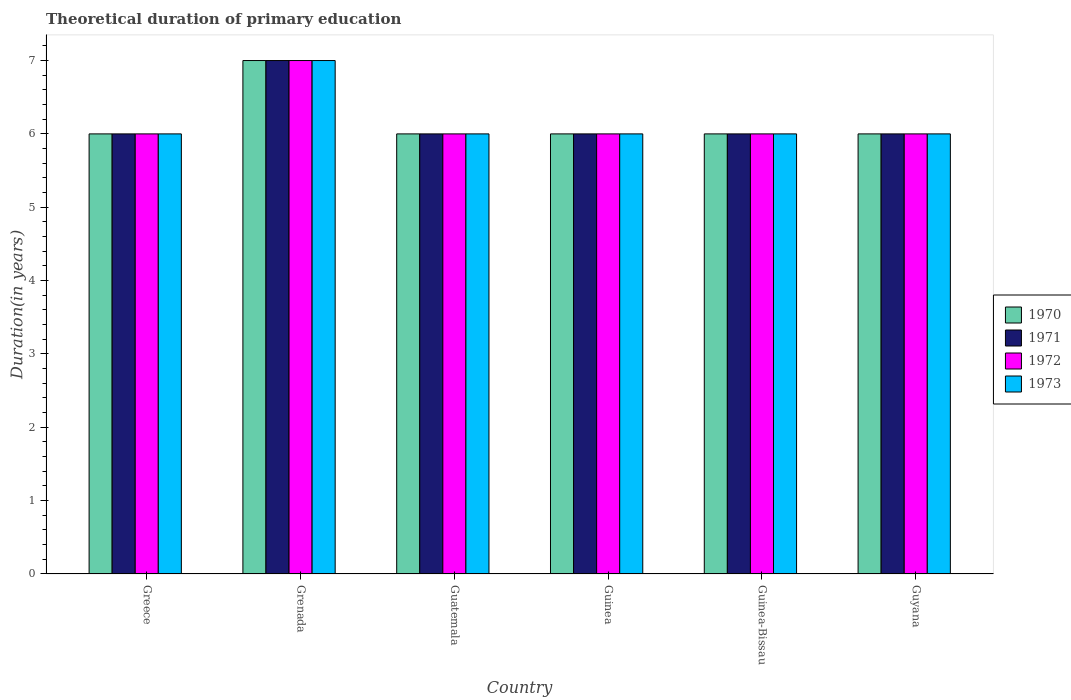How many groups of bars are there?
Your answer should be compact. 6. Are the number of bars on each tick of the X-axis equal?
Keep it short and to the point. Yes. How many bars are there on the 5th tick from the left?
Offer a very short reply. 4. How many bars are there on the 4th tick from the right?
Make the answer very short. 4. What is the label of the 1st group of bars from the left?
Provide a short and direct response. Greece. In how many cases, is the number of bars for a given country not equal to the number of legend labels?
Your response must be concise. 0. Across all countries, what is the maximum total theoretical duration of primary education in 1971?
Your answer should be very brief. 7. In which country was the total theoretical duration of primary education in 1973 maximum?
Make the answer very short. Grenada. In which country was the total theoretical duration of primary education in 1971 minimum?
Ensure brevity in your answer.  Greece. What is the difference between the total theoretical duration of primary education in 1971 in Guatemala and the total theoretical duration of primary education in 1972 in Guinea?
Offer a very short reply. 0. What is the average total theoretical duration of primary education in 1972 per country?
Your answer should be compact. 6.17. What is the difference between the total theoretical duration of primary education of/in 1971 and total theoretical duration of primary education of/in 1970 in Guinea?
Offer a terse response. 0. In how many countries, is the total theoretical duration of primary education in 1970 greater than 1.6 years?
Ensure brevity in your answer.  6. What is the ratio of the total theoretical duration of primary education in 1972 in Grenada to that in Guyana?
Ensure brevity in your answer.  1.17. Is the difference between the total theoretical duration of primary education in 1971 in Guinea-Bissau and Guyana greater than the difference between the total theoretical duration of primary education in 1970 in Guinea-Bissau and Guyana?
Provide a succinct answer. No. What is the difference between the highest and the lowest total theoretical duration of primary education in 1972?
Keep it short and to the point. 1. In how many countries, is the total theoretical duration of primary education in 1971 greater than the average total theoretical duration of primary education in 1971 taken over all countries?
Provide a short and direct response. 1. What does the 4th bar from the left in Greece represents?
Offer a terse response. 1973. What does the 4th bar from the right in Guinea-Bissau represents?
Give a very brief answer. 1970. Are all the bars in the graph horizontal?
Give a very brief answer. No. How many countries are there in the graph?
Your answer should be very brief. 6. Are the values on the major ticks of Y-axis written in scientific E-notation?
Offer a very short reply. No. Does the graph contain any zero values?
Your answer should be very brief. No. Does the graph contain grids?
Provide a short and direct response. No. How many legend labels are there?
Ensure brevity in your answer.  4. What is the title of the graph?
Provide a short and direct response. Theoretical duration of primary education. What is the label or title of the Y-axis?
Ensure brevity in your answer.  Duration(in years). What is the Duration(in years) in 1970 in Greece?
Give a very brief answer. 6. What is the Duration(in years) in 1972 in Greece?
Offer a very short reply. 6. What is the Duration(in years) of 1970 in Grenada?
Provide a succinct answer. 7. What is the Duration(in years) in 1972 in Grenada?
Ensure brevity in your answer.  7. What is the Duration(in years) in 1973 in Grenada?
Offer a very short reply. 7. What is the Duration(in years) of 1972 in Guatemala?
Give a very brief answer. 6. What is the Duration(in years) in 1973 in Guatemala?
Your answer should be very brief. 6. What is the Duration(in years) of 1970 in Guinea?
Offer a very short reply. 6. What is the Duration(in years) in 1971 in Guinea?
Keep it short and to the point. 6. What is the Duration(in years) in 1973 in Guinea?
Offer a very short reply. 6. What is the Duration(in years) in 1971 in Guinea-Bissau?
Offer a very short reply. 6. What is the Duration(in years) of 1970 in Guyana?
Keep it short and to the point. 6. What is the Duration(in years) of 1971 in Guyana?
Your answer should be very brief. 6. Across all countries, what is the maximum Duration(in years) in 1973?
Your answer should be compact. 7. What is the total Duration(in years) of 1971 in the graph?
Provide a short and direct response. 37. What is the total Duration(in years) of 1972 in the graph?
Offer a very short reply. 37. What is the difference between the Duration(in years) of 1972 in Greece and that in Grenada?
Your answer should be very brief. -1. What is the difference between the Duration(in years) of 1973 in Greece and that in Grenada?
Keep it short and to the point. -1. What is the difference between the Duration(in years) of 1971 in Greece and that in Guatemala?
Your answer should be very brief. 0. What is the difference between the Duration(in years) of 1972 in Greece and that in Guatemala?
Ensure brevity in your answer.  0. What is the difference between the Duration(in years) of 1972 in Greece and that in Guinea?
Keep it short and to the point. 0. What is the difference between the Duration(in years) in 1973 in Greece and that in Guinea?
Give a very brief answer. 0. What is the difference between the Duration(in years) of 1971 in Greece and that in Guinea-Bissau?
Your answer should be very brief. 0. What is the difference between the Duration(in years) of 1972 in Greece and that in Guinea-Bissau?
Provide a succinct answer. 0. What is the difference between the Duration(in years) of 1971 in Greece and that in Guyana?
Give a very brief answer. 0. What is the difference between the Duration(in years) in 1972 in Greece and that in Guyana?
Keep it short and to the point. 0. What is the difference between the Duration(in years) of 1973 in Greece and that in Guyana?
Your response must be concise. 0. What is the difference between the Duration(in years) in 1970 in Grenada and that in Guatemala?
Your response must be concise. 1. What is the difference between the Duration(in years) of 1971 in Grenada and that in Guatemala?
Offer a terse response. 1. What is the difference between the Duration(in years) of 1972 in Grenada and that in Guatemala?
Your response must be concise. 1. What is the difference between the Duration(in years) in 1972 in Grenada and that in Guinea?
Provide a succinct answer. 1. What is the difference between the Duration(in years) in 1973 in Grenada and that in Guinea?
Give a very brief answer. 1. What is the difference between the Duration(in years) in 1970 in Grenada and that in Guinea-Bissau?
Offer a very short reply. 1. What is the difference between the Duration(in years) of 1973 in Grenada and that in Guinea-Bissau?
Keep it short and to the point. 1. What is the difference between the Duration(in years) in 1970 in Guatemala and that in Guinea?
Provide a succinct answer. 0. What is the difference between the Duration(in years) of 1971 in Guatemala and that in Guinea?
Provide a succinct answer. 0. What is the difference between the Duration(in years) in 1972 in Guatemala and that in Guinea?
Your answer should be very brief. 0. What is the difference between the Duration(in years) of 1971 in Guatemala and that in Guinea-Bissau?
Your response must be concise. 0. What is the difference between the Duration(in years) in 1973 in Guatemala and that in Guinea-Bissau?
Offer a very short reply. 0. What is the difference between the Duration(in years) in 1970 in Guatemala and that in Guyana?
Ensure brevity in your answer.  0. What is the difference between the Duration(in years) in 1972 in Guatemala and that in Guyana?
Offer a very short reply. 0. What is the difference between the Duration(in years) of 1971 in Guinea and that in Guyana?
Your answer should be very brief. 0. What is the difference between the Duration(in years) of 1970 in Guinea-Bissau and that in Guyana?
Your answer should be very brief. 0. What is the difference between the Duration(in years) in 1972 in Guinea-Bissau and that in Guyana?
Your answer should be compact. 0. What is the difference between the Duration(in years) of 1970 in Greece and the Duration(in years) of 1971 in Grenada?
Make the answer very short. -1. What is the difference between the Duration(in years) of 1970 in Greece and the Duration(in years) of 1972 in Grenada?
Your response must be concise. -1. What is the difference between the Duration(in years) of 1970 in Greece and the Duration(in years) of 1973 in Grenada?
Offer a very short reply. -1. What is the difference between the Duration(in years) in 1971 in Greece and the Duration(in years) in 1972 in Guatemala?
Give a very brief answer. 0. What is the difference between the Duration(in years) in 1971 in Greece and the Duration(in years) in 1973 in Guatemala?
Your response must be concise. 0. What is the difference between the Duration(in years) in 1971 in Greece and the Duration(in years) in 1973 in Guinea?
Your answer should be compact. 0. What is the difference between the Duration(in years) of 1970 in Greece and the Duration(in years) of 1973 in Guinea-Bissau?
Keep it short and to the point. 0. What is the difference between the Duration(in years) in 1971 in Greece and the Duration(in years) in 1972 in Guinea-Bissau?
Keep it short and to the point. 0. What is the difference between the Duration(in years) in 1971 in Greece and the Duration(in years) in 1973 in Guinea-Bissau?
Offer a very short reply. 0. What is the difference between the Duration(in years) in 1972 in Greece and the Duration(in years) in 1973 in Guinea-Bissau?
Give a very brief answer. 0. What is the difference between the Duration(in years) in 1970 in Greece and the Duration(in years) in 1971 in Guyana?
Offer a very short reply. 0. What is the difference between the Duration(in years) of 1972 in Greece and the Duration(in years) of 1973 in Guyana?
Keep it short and to the point. 0. What is the difference between the Duration(in years) of 1970 in Grenada and the Duration(in years) of 1973 in Guatemala?
Ensure brevity in your answer.  1. What is the difference between the Duration(in years) in 1971 in Grenada and the Duration(in years) in 1973 in Guatemala?
Your response must be concise. 1. What is the difference between the Duration(in years) in 1972 in Grenada and the Duration(in years) in 1973 in Guatemala?
Your answer should be compact. 1. What is the difference between the Duration(in years) in 1970 in Grenada and the Duration(in years) in 1972 in Guinea?
Ensure brevity in your answer.  1. What is the difference between the Duration(in years) of 1972 in Grenada and the Duration(in years) of 1973 in Guinea?
Make the answer very short. 1. What is the difference between the Duration(in years) of 1971 in Grenada and the Duration(in years) of 1972 in Guinea-Bissau?
Your response must be concise. 1. What is the difference between the Duration(in years) of 1972 in Grenada and the Duration(in years) of 1973 in Guinea-Bissau?
Offer a very short reply. 1. What is the difference between the Duration(in years) of 1970 in Grenada and the Duration(in years) of 1973 in Guyana?
Ensure brevity in your answer.  1. What is the difference between the Duration(in years) in 1971 in Grenada and the Duration(in years) in 1972 in Guyana?
Offer a very short reply. 1. What is the difference between the Duration(in years) of 1971 in Grenada and the Duration(in years) of 1973 in Guyana?
Keep it short and to the point. 1. What is the difference between the Duration(in years) in 1970 in Guatemala and the Duration(in years) in 1972 in Guinea?
Your answer should be very brief. 0. What is the difference between the Duration(in years) in 1970 in Guatemala and the Duration(in years) in 1973 in Guinea?
Ensure brevity in your answer.  0. What is the difference between the Duration(in years) of 1972 in Guatemala and the Duration(in years) of 1973 in Guinea?
Provide a succinct answer. 0. What is the difference between the Duration(in years) of 1970 in Guatemala and the Duration(in years) of 1971 in Guinea-Bissau?
Provide a succinct answer. 0. What is the difference between the Duration(in years) in 1970 in Guatemala and the Duration(in years) in 1972 in Guinea-Bissau?
Your response must be concise. 0. What is the difference between the Duration(in years) of 1970 in Guatemala and the Duration(in years) of 1973 in Guinea-Bissau?
Ensure brevity in your answer.  0. What is the difference between the Duration(in years) in 1971 in Guatemala and the Duration(in years) in 1972 in Guinea-Bissau?
Your answer should be compact. 0. What is the difference between the Duration(in years) in 1970 in Guatemala and the Duration(in years) in 1971 in Guyana?
Your response must be concise. 0. What is the difference between the Duration(in years) of 1970 in Guatemala and the Duration(in years) of 1973 in Guyana?
Offer a terse response. 0. What is the difference between the Duration(in years) in 1971 in Guatemala and the Duration(in years) in 1973 in Guyana?
Your answer should be compact. 0. What is the difference between the Duration(in years) in 1972 in Guatemala and the Duration(in years) in 1973 in Guyana?
Offer a very short reply. 0. What is the difference between the Duration(in years) in 1970 in Guinea and the Duration(in years) in 1971 in Guinea-Bissau?
Give a very brief answer. 0. What is the difference between the Duration(in years) of 1970 in Guinea and the Duration(in years) of 1971 in Guyana?
Your answer should be very brief. 0. What is the difference between the Duration(in years) of 1970 in Guinea and the Duration(in years) of 1972 in Guyana?
Your answer should be very brief. 0. What is the difference between the Duration(in years) of 1971 in Guinea and the Duration(in years) of 1972 in Guyana?
Offer a terse response. 0. What is the difference between the Duration(in years) of 1970 in Guinea-Bissau and the Duration(in years) of 1972 in Guyana?
Keep it short and to the point. 0. What is the difference between the Duration(in years) of 1970 in Guinea-Bissau and the Duration(in years) of 1973 in Guyana?
Make the answer very short. 0. What is the difference between the Duration(in years) in 1971 in Guinea-Bissau and the Duration(in years) in 1972 in Guyana?
Give a very brief answer. 0. What is the average Duration(in years) in 1970 per country?
Provide a succinct answer. 6.17. What is the average Duration(in years) in 1971 per country?
Provide a succinct answer. 6.17. What is the average Duration(in years) of 1972 per country?
Make the answer very short. 6.17. What is the average Duration(in years) in 1973 per country?
Provide a succinct answer. 6.17. What is the difference between the Duration(in years) of 1970 and Duration(in years) of 1972 in Greece?
Offer a very short reply. 0. What is the difference between the Duration(in years) in 1971 and Duration(in years) in 1972 in Greece?
Your answer should be very brief. 0. What is the difference between the Duration(in years) of 1970 and Duration(in years) of 1972 in Grenada?
Provide a succinct answer. 0. What is the difference between the Duration(in years) of 1971 and Duration(in years) of 1972 in Grenada?
Your answer should be compact. 0. What is the difference between the Duration(in years) of 1972 and Duration(in years) of 1973 in Grenada?
Make the answer very short. 0. What is the difference between the Duration(in years) of 1970 and Duration(in years) of 1972 in Guatemala?
Offer a very short reply. 0. What is the difference between the Duration(in years) in 1971 and Duration(in years) in 1973 in Guatemala?
Make the answer very short. 0. What is the difference between the Duration(in years) of 1972 and Duration(in years) of 1973 in Guatemala?
Make the answer very short. 0. What is the difference between the Duration(in years) in 1970 and Duration(in years) in 1971 in Guinea?
Provide a short and direct response. 0. What is the difference between the Duration(in years) in 1970 and Duration(in years) in 1973 in Guinea?
Your answer should be compact. 0. What is the difference between the Duration(in years) in 1971 and Duration(in years) in 1972 in Guinea?
Provide a succinct answer. 0. What is the difference between the Duration(in years) in 1971 and Duration(in years) in 1973 in Guinea?
Give a very brief answer. 0. What is the difference between the Duration(in years) of 1972 and Duration(in years) of 1973 in Guinea?
Provide a succinct answer. 0. What is the difference between the Duration(in years) of 1970 and Duration(in years) of 1972 in Guinea-Bissau?
Provide a short and direct response. 0. What is the difference between the Duration(in years) of 1970 and Duration(in years) of 1973 in Guinea-Bissau?
Your response must be concise. 0. What is the difference between the Duration(in years) in 1971 and Duration(in years) in 1972 in Guinea-Bissau?
Give a very brief answer. 0. What is the difference between the Duration(in years) of 1970 and Duration(in years) of 1971 in Guyana?
Offer a very short reply. 0. What is the difference between the Duration(in years) of 1971 and Duration(in years) of 1973 in Guyana?
Provide a succinct answer. 0. What is the difference between the Duration(in years) of 1972 and Duration(in years) of 1973 in Guyana?
Your response must be concise. 0. What is the ratio of the Duration(in years) of 1970 in Greece to that in Guatemala?
Provide a succinct answer. 1. What is the ratio of the Duration(in years) in 1971 in Greece to that in Guatemala?
Your answer should be compact. 1. What is the ratio of the Duration(in years) in 1973 in Greece to that in Guatemala?
Make the answer very short. 1. What is the ratio of the Duration(in years) in 1971 in Greece to that in Guinea?
Ensure brevity in your answer.  1. What is the ratio of the Duration(in years) of 1972 in Greece to that in Guinea?
Keep it short and to the point. 1. What is the ratio of the Duration(in years) of 1971 in Greece to that in Guinea-Bissau?
Keep it short and to the point. 1. What is the ratio of the Duration(in years) of 1970 in Greece to that in Guyana?
Provide a succinct answer. 1. What is the ratio of the Duration(in years) in 1973 in Greece to that in Guyana?
Your answer should be compact. 1. What is the ratio of the Duration(in years) in 1970 in Grenada to that in Guatemala?
Make the answer very short. 1.17. What is the ratio of the Duration(in years) in 1971 in Grenada to that in Guatemala?
Provide a short and direct response. 1.17. What is the ratio of the Duration(in years) in 1972 in Grenada to that in Guatemala?
Provide a succinct answer. 1.17. What is the ratio of the Duration(in years) of 1971 in Grenada to that in Guinea?
Keep it short and to the point. 1.17. What is the ratio of the Duration(in years) in 1973 in Grenada to that in Guinea?
Keep it short and to the point. 1.17. What is the ratio of the Duration(in years) of 1971 in Grenada to that in Guinea-Bissau?
Your response must be concise. 1.17. What is the ratio of the Duration(in years) in 1970 in Grenada to that in Guyana?
Give a very brief answer. 1.17. What is the ratio of the Duration(in years) of 1971 in Grenada to that in Guyana?
Offer a terse response. 1.17. What is the ratio of the Duration(in years) of 1972 in Grenada to that in Guyana?
Provide a succinct answer. 1.17. What is the ratio of the Duration(in years) of 1973 in Grenada to that in Guyana?
Keep it short and to the point. 1.17. What is the ratio of the Duration(in years) in 1972 in Guatemala to that in Guinea?
Give a very brief answer. 1. What is the ratio of the Duration(in years) of 1973 in Guatemala to that in Guinea?
Provide a short and direct response. 1. What is the ratio of the Duration(in years) in 1970 in Guatemala to that in Guinea-Bissau?
Keep it short and to the point. 1. What is the ratio of the Duration(in years) in 1971 in Guatemala to that in Guinea-Bissau?
Your answer should be very brief. 1. What is the ratio of the Duration(in years) in 1973 in Guatemala to that in Guyana?
Ensure brevity in your answer.  1. What is the ratio of the Duration(in years) of 1972 in Guinea to that in Guinea-Bissau?
Offer a very short reply. 1. What is the ratio of the Duration(in years) in 1970 in Guinea to that in Guyana?
Your response must be concise. 1. What is the difference between the highest and the second highest Duration(in years) of 1972?
Provide a short and direct response. 1. What is the difference between the highest and the lowest Duration(in years) in 1971?
Make the answer very short. 1. What is the difference between the highest and the lowest Duration(in years) in 1973?
Make the answer very short. 1. 